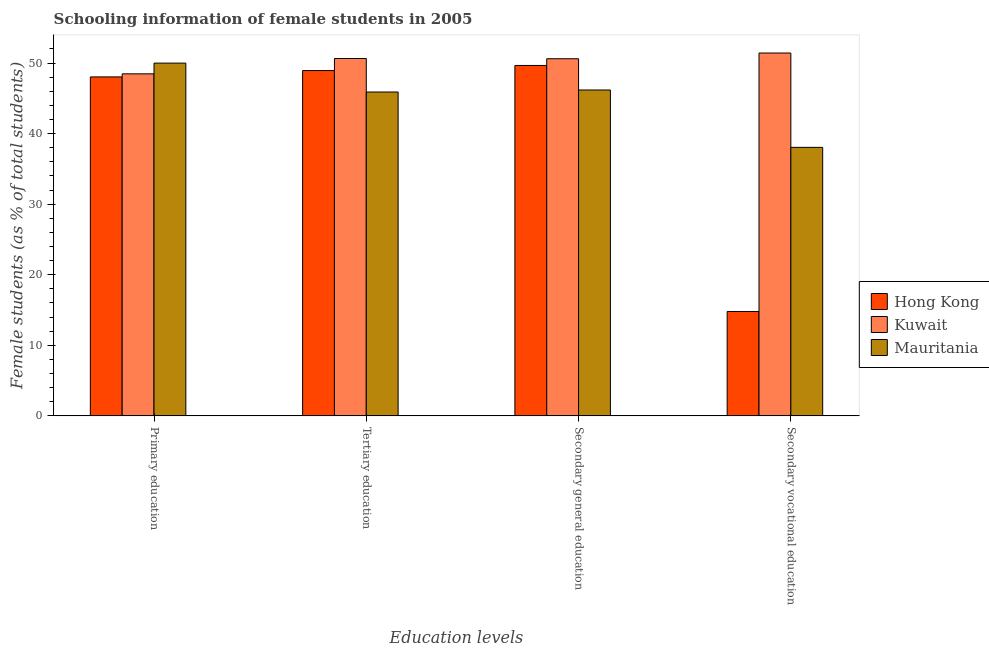What is the label of the 3rd group of bars from the left?
Provide a succinct answer. Secondary general education. What is the percentage of female students in secondary vocational education in Kuwait?
Your response must be concise. 51.42. Across all countries, what is the maximum percentage of female students in secondary vocational education?
Keep it short and to the point. 51.42. Across all countries, what is the minimum percentage of female students in secondary education?
Provide a succinct answer. 46.18. In which country was the percentage of female students in secondary vocational education maximum?
Give a very brief answer. Kuwait. In which country was the percentage of female students in secondary education minimum?
Offer a very short reply. Mauritania. What is the total percentage of female students in tertiary education in the graph?
Offer a terse response. 145.48. What is the difference between the percentage of female students in secondary vocational education in Kuwait and that in Hong Kong?
Keep it short and to the point. 36.63. What is the difference between the percentage of female students in secondary vocational education in Kuwait and the percentage of female students in secondary education in Hong Kong?
Offer a terse response. 1.76. What is the average percentage of female students in tertiary education per country?
Offer a very short reply. 48.49. What is the difference between the percentage of female students in secondary education and percentage of female students in primary education in Hong Kong?
Offer a very short reply. 1.62. In how many countries, is the percentage of female students in secondary education greater than 30 %?
Ensure brevity in your answer.  3. What is the ratio of the percentage of female students in primary education in Hong Kong to that in Kuwait?
Make the answer very short. 0.99. Is the difference between the percentage of female students in secondary education in Mauritania and Kuwait greater than the difference between the percentage of female students in secondary vocational education in Mauritania and Kuwait?
Your answer should be compact. Yes. What is the difference between the highest and the second highest percentage of female students in secondary education?
Provide a short and direct response. 0.95. What is the difference between the highest and the lowest percentage of female students in secondary vocational education?
Offer a very short reply. 36.63. What does the 3rd bar from the left in Tertiary education represents?
Offer a very short reply. Mauritania. What does the 3rd bar from the right in Primary education represents?
Your answer should be compact. Hong Kong. How many countries are there in the graph?
Offer a very short reply. 3. Are the values on the major ticks of Y-axis written in scientific E-notation?
Your answer should be very brief. No. Does the graph contain any zero values?
Provide a succinct answer. No. Where does the legend appear in the graph?
Ensure brevity in your answer.  Center right. How are the legend labels stacked?
Provide a short and direct response. Vertical. What is the title of the graph?
Your answer should be compact. Schooling information of female students in 2005. What is the label or title of the X-axis?
Your answer should be compact. Education levels. What is the label or title of the Y-axis?
Keep it short and to the point. Female students (as % of total students). What is the Female students (as % of total students) of Hong Kong in Primary education?
Provide a short and direct response. 48.04. What is the Female students (as % of total students) of Kuwait in Primary education?
Your response must be concise. 48.47. What is the Female students (as % of total students) of Mauritania in Primary education?
Make the answer very short. 49.99. What is the Female students (as % of total students) in Hong Kong in Tertiary education?
Your response must be concise. 48.94. What is the Female students (as % of total students) of Kuwait in Tertiary education?
Make the answer very short. 50.65. What is the Female students (as % of total students) of Mauritania in Tertiary education?
Keep it short and to the point. 45.9. What is the Female students (as % of total students) in Hong Kong in Secondary general education?
Provide a succinct answer. 49.66. What is the Female students (as % of total students) in Kuwait in Secondary general education?
Your answer should be very brief. 50.61. What is the Female students (as % of total students) of Mauritania in Secondary general education?
Offer a terse response. 46.18. What is the Female students (as % of total students) in Hong Kong in Secondary vocational education?
Your answer should be compact. 14.79. What is the Female students (as % of total students) in Kuwait in Secondary vocational education?
Provide a short and direct response. 51.42. What is the Female students (as % of total students) of Mauritania in Secondary vocational education?
Your answer should be very brief. 38.05. Across all Education levels, what is the maximum Female students (as % of total students) in Hong Kong?
Your answer should be compact. 49.66. Across all Education levels, what is the maximum Female students (as % of total students) of Kuwait?
Provide a short and direct response. 51.42. Across all Education levels, what is the maximum Female students (as % of total students) of Mauritania?
Give a very brief answer. 49.99. Across all Education levels, what is the minimum Female students (as % of total students) of Hong Kong?
Provide a succinct answer. 14.79. Across all Education levels, what is the minimum Female students (as % of total students) of Kuwait?
Your response must be concise. 48.47. Across all Education levels, what is the minimum Female students (as % of total students) in Mauritania?
Give a very brief answer. 38.05. What is the total Female students (as % of total students) in Hong Kong in the graph?
Offer a very short reply. 161.43. What is the total Female students (as % of total students) of Kuwait in the graph?
Your response must be concise. 201.16. What is the total Female students (as % of total students) in Mauritania in the graph?
Your answer should be compact. 180.13. What is the difference between the Female students (as % of total students) of Hong Kong in Primary education and that in Tertiary education?
Your response must be concise. -0.9. What is the difference between the Female students (as % of total students) in Kuwait in Primary education and that in Tertiary education?
Provide a succinct answer. -2.17. What is the difference between the Female students (as % of total students) of Mauritania in Primary education and that in Tertiary education?
Keep it short and to the point. 4.1. What is the difference between the Female students (as % of total students) in Hong Kong in Primary education and that in Secondary general education?
Make the answer very short. -1.62. What is the difference between the Female students (as % of total students) in Kuwait in Primary education and that in Secondary general education?
Your response must be concise. -2.14. What is the difference between the Female students (as % of total students) in Mauritania in Primary education and that in Secondary general education?
Your answer should be very brief. 3.81. What is the difference between the Female students (as % of total students) of Hong Kong in Primary education and that in Secondary vocational education?
Offer a terse response. 33.24. What is the difference between the Female students (as % of total students) in Kuwait in Primary education and that in Secondary vocational education?
Make the answer very short. -2.95. What is the difference between the Female students (as % of total students) of Mauritania in Primary education and that in Secondary vocational education?
Offer a very short reply. 11.94. What is the difference between the Female students (as % of total students) of Hong Kong in Tertiary education and that in Secondary general education?
Offer a very short reply. -0.72. What is the difference between the Female students (as % of total students) in Kuwait in Tertiary education and that in Secondary general education?
Make the answer very short. 0.03. What is the difference between the Female students (as % of total students) of Mauritania in Tertiary education and that in Secondary general education?
Offer a very short reply. -0.29. What is the difference between the Female students (as % of total students) of Hong Kong in Tertiary education and that in Secondary vocational education?
Give a very brief answer. 34.14. What is the difference between the Female students (as % of total students) of Kuwait in Tertiary education and that in Secondary vocational education?
Your response must be concise. -0.78. What is the difference between the Female students (as % of total students) in Mauritania in Tertiary education and that in Secondary vocational education?
Make the answer very short. 7.84. What is the difference between the Female students (as % of total students) of Hong Kong in Secondary general education and that in Secondary vocational education?
Your answer should be compact. 34.87. What is the difference between the Female students (as % of total students) of Kuwait in Secondary general education and that in Secondary vocational education?
Keep it short and to the point. -0.81. What is the difference between the Female students (as % of total students) in Mauritania in Secondary general education and that in Secondary vocational education?
Offer a very short reply. 8.13. What is the difference between the Female students (as % of total students) in Hong Kong in Primary education and the Female students (as % of total students) in Kuwait in Tertiary education?
Ensure brevity in your answer.  -2.61. What is the difference between the Female students (as % of total students) in Hong Kong in Primary education and the Female students (as % of total students) in Mauritania in Tertiary education?
Your response must be concise. 2.14. What is the difference between the Female students (as % of total students) of Kuwait in Primary education and the Female students (as % of total students) of Mauritania in Tertiary education?
Keep it short and to the point. 2.58. What is the difference between the Female students (as % of total students) of Hong Kong in Primary education and the Female students (as % of total students) of Kuwait in Secondary general education?
Make the answer very short. -2.58. What is the difference between the Female students (as % of total students) of Hong Kong in Primary education and the Female students (as % of total students) of Mauritania in Secondary general education?
Provide a short and direct response. 1.85. What is the difference between the Female students (as % of total students) of Kuwait in Primary education and the Female students (as % of total students) of Mauritania in Secondary general education?
Provide a succinct answer. 2.29. What is the difference between the Female students (as % of total students) in Hong Kong in Primary education and the Female students (as % of total students) in Kuwait in Secondary vocational education?
Ensure brevity in your answer.  -3.39. What is the difference between the Female students (as % of total students) in Hong Kong in Primary education and the Female students (as % of total students) in Mauritania in Secondary vocational education?
Provide a short and direct response. 9.98. What is the difference between the Female students (as % of total students) of Kuwait in Primary education and the Female students (as % of total students) of Mauritania in Secondary vocational education?
Provide a short and direct response. 10.42. What is the difference between the Female students (as % of total students) of Hong Kong in Tertiary education and the Female students (as % of total students) of Kuwait in Secondary general education?
Offer a very short reply. -1.68. What is the difference between the Female students (as % of total students) in Hong Kong in Tertiary education and the Female students (as % of total students) in Mauritania in Secondary general education?
Your response must be concise. 2.75. What is the difference between the Female students (as % of total students) of Kuwait in Tertiary education and the Female students (as % of total students) of Mauritania in Secondary general education?
Your answer should be compact. 4.46. What is the difference between the Female students (as % of total students) in Hong Kong in Tertiary education and the Female students (as % of total students) in Kuwait in Secondary vocational education?
Make the answer very short. -2.49. What is the difference between the Female students (as % of total students) in Hong Kong in Tertiary education and the Female students (as % of total students) in Mauritania in Secondary vocational education?
Offer a very short reply. 10.88. What is the difference between the Female students (as % of total students) of Kuwait in Tertiary education and the Female students (as % of total students) of Mauritania in Secondary vocational education?
Your answer should be very brief. 12.59. What is the difference between the Female students (as % of total students) in Hong Kong in Secondary general education and the Female students (as % of total students) in Kuwait in Secondary vocational education?
Keep it short and to the point. -1.76. What is the difference between the Female students (as % of total students) of Hong Kong in Secondary general education and the Female students (as % of total students) of Mauritania in Secondary vocational education?
Ensure brevity in your answer.  11.61. What is the difference between the Female students (as % of total students) of Kuwait in Secondary general education and the Female students (as % of total students) of Mauritania in Secondary vocational education?
Your response must be concise. 12.56. What is the average Female students (as % of total students) of Hong Kong per Education levels?
Ensure brevity in your answer.  40.36. What is the average Female students (as % of total students) of Kuwait per Education levels?
Your answer should be compact. 50.29. What is the average Female students (as % of total students) in Mauritania per Education levels?
Your answer should be compact. 45.03. What is the difference between the Female students (as % of total students) of Hong Kong and Female students (as % of total students) of Kuwait in Primary education?
Make the answer very short. -0.44. What is the difference between the Female students (as % of total students) of Hong Kong and Female students (as % of total students) of Mauritania in Primary education?
Ensure brevity in your answer.  -1.96. What is the difference between the Female students (as % of total students) of Kuwait and Female students (as % of total students) of Mauritania in Primary education?
Ensure brevity in your answer.  -1.52. What is the difference between the Female students (as % of total students) in Hong Kong and Female students (as % of total students) in Kuwait in Tertiary education?
Offer a very short reply. -1.71. What is the difference between the Female students (as % of total students) in Hong Kong and Female students (as % of total students) in Mauritania in Tertiary education?
Make the answer very short. 3.04. What is the difference between the Female students (as % of total students) of Kuwait and Female students (as % of total students) of Mauritania in Tertiary education?
Provide a short and direct response. 4.75. What is the difference between the Female students (as % of total students) of Hong Kong and Female students (as % of total students) of Kuwait in Secondary general education?
Offer a very short reply. -0.95. What is the difference between the Female students (as % of total students) in Hong Kong and Female students (as % of total students) in Mauritania in Secondary general education?
Give a very brief answer. 3.48. What is the difference between the Female students (as % of total students) in Kuwait and Female students (as % of total students) in Mauritania in Secondary general education?
Your response must be concise. 4.43. What is the difference between the Female students (as % of total students) in Hong Kong and Female students (as % of total students) in Kuwait in Secondary vocational education?
Offer a terse response. -36.63. What is the difference between the Female students (as % of total students) in Hong Kong and Female students (as % of total students) in Mauritania in Secondary vocational education?
Provide a short and direct response. -23.26. What is the difference between the Female students (as % of total students) of Kuwait and Female students (as % of total students) of Mauritania in Secondary vocational education?
Keep it short and to the point. 13.37. What is the ratio of the Female students (as % of total students) of Hong Kong in Primary education to that in Tertiary education?
Provide a short and direct response. 0.98. What is the ratio of the Female students (as % of total students) in Kuwait in Primary education to that in Tertiary education?
Keep it short and to the point. 0.96. What is the ratio of the Female students (as % of total students) in Mauritania in Primary education to that in Tertiary education?
Keep it short and to the point. 1.09. What is the ratio of the Female students (as % of total students) of Hong Kong in Primary education to that in Secondary general education?
Provide a succinct answer. 0.97. What is the ratio of the Female students (as % of total students) in Kuwait in Primary education to that in Secondary general education?
Offer a very short reply. 0.96. What is the ratio of the Female students (as % of total students) of Mauritania in Primary education to that in Secondary general education?
Offer a terse response. 1.08. What is the ratio of the Female students (as % of total students) in Hong Kong in Primary education to that in Secondary vocational education?
Ensure brevity in your answer.  3.25. What is the ratio of the Female students (as % of total students) of Kuwait in Primary education to that in Secondary vocational education?
Give a very brief answer. 0.94. What is the ratio of the Female students (as % of total students) of Mauritania in Primary education to that in Secondary vocational education?
Your answer should be very brief. 1.31. What is the ratio of the Female students (as % of total students) of Hong Kong in Tertiary education to that in Secondary general education?
Your answer should be very brief. 0.99. What is the ratio of the Female students (as % of total students) in Kuwait in Tertiary education to that in Secondary general education?
Your response must be concise. 1. What is the ratio of the Female students (as % of total students) of Hong Kong in Tertiary education to that in Secondary vocational education?
Your answer should be very brief. 3.31. What is the ratio of the Female students (as % of total students) of Kuwait in Tertiary education to that in Secondary vocational education?
Ensure brevity in your answer.  0.98. What is the ratio of the Female students (as % of total students) of Mauritania in Tertiary education to that in Secondary vocational education?
Provide a short and direct response. 1.21. What is the ratio of the Female students (as % of total students) in Hong Kong in Secondary general education to that in Secondary vocational education?
Provide a succinct answer. 3.36. What is the ratio of the Female students (as % of total students) in Kuwait in Secondary general education to that in Secondary vocational education?
Give a very brief answer. 0.98. What is the ratio of the Female students (as % of total students) of Mauritania in Secondary general education to that in Secondary vocational education?
Your answer should be compact. 1.21. What is the difference between the highest and the second highest Female students (as % of total students) in Hong Kong?
Provide a short and direct response. 0.72. What is the difference between the highest and the second highest Female students (as % of total students) of Kuwait?
Offer a terse response. 0.78. What is the difference between the highest and the second highest Female students (as % of total students) of Mauritania?
Keep it short and to the point. 3.81. What is the difference between the highest and the lowest Female students (as % of total students) in Hong Kong?
Give a very brief answer. 34.87. What is the difference between the highest and the lowest Female students (as % of total students) in Kuwait?
Make the answer very short. 2.95. What is the difference between the highest and the lowest Female students (as % of total students) of Mauritania?
Provide a short and direct response. 11.94. 